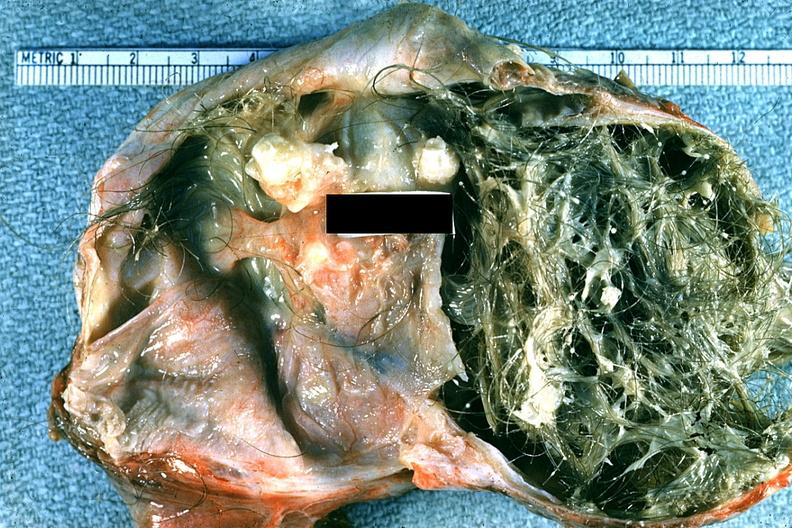s female reproductive present?
Answer the question using a single word or phrase. Yes 